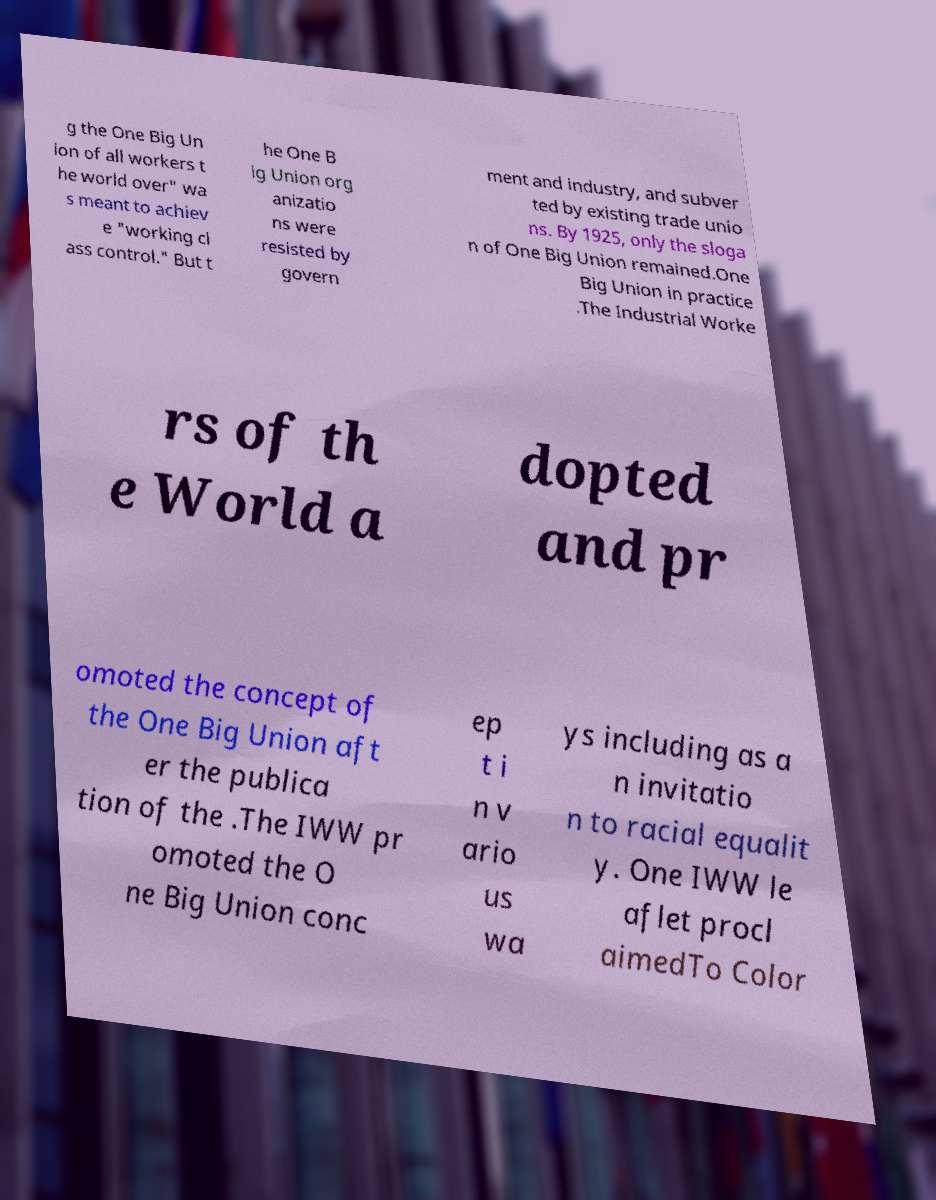What messages or text are displayed in this image? I need them in a readable, typed format. g the One Big Un ion of all workers t he world over" wa s meant to achiev e "working cl ass control." But t he One B ig Union org anizatio ns were resisted by govern ment and industry, and subver ted by existing trade unio ns. By 1925, only the sloga n of One Big Union remained.One Big Union in practice .The Industrial Worke rs of th e World a dopted and pr omoted the concept of the One Big Union aft er the publica tion of the .The IWW pr omoted the O ne Big Union conc ep t i n v ario us wa ys including as a n invitatio n to racial equalit y. One IWW le aflet procl aimedTo Color 